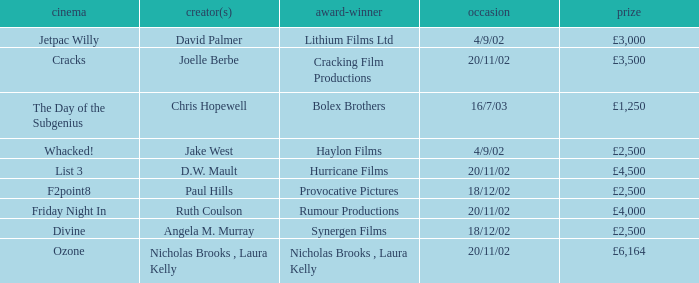Who directed a film for Cracking Film Productions? Joelle Berbe. 